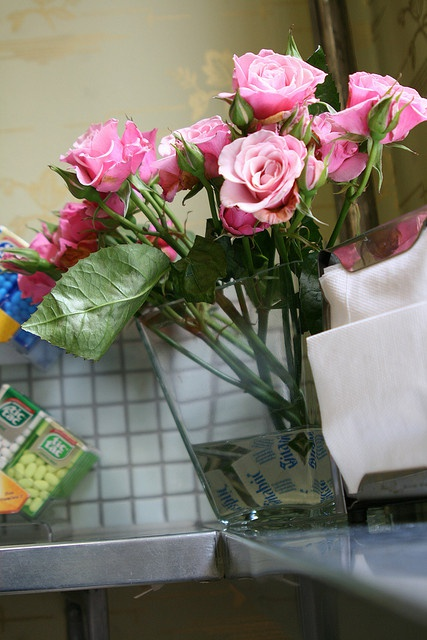Describe the objects in this image and their specific colors. I can see a vase in darkgray, black, gray, and darkgreen tones in this image. 